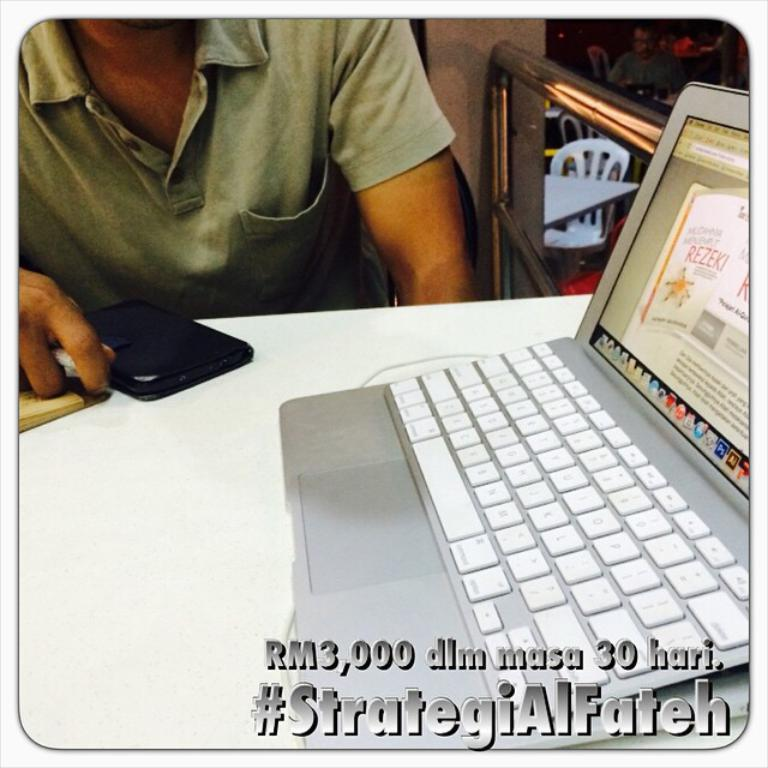<image>
Offer a succinct explanation of the picture presented. A person is sitting at a table that holds a laptop, and #StrategiAIFateh is superimposed on the image. 